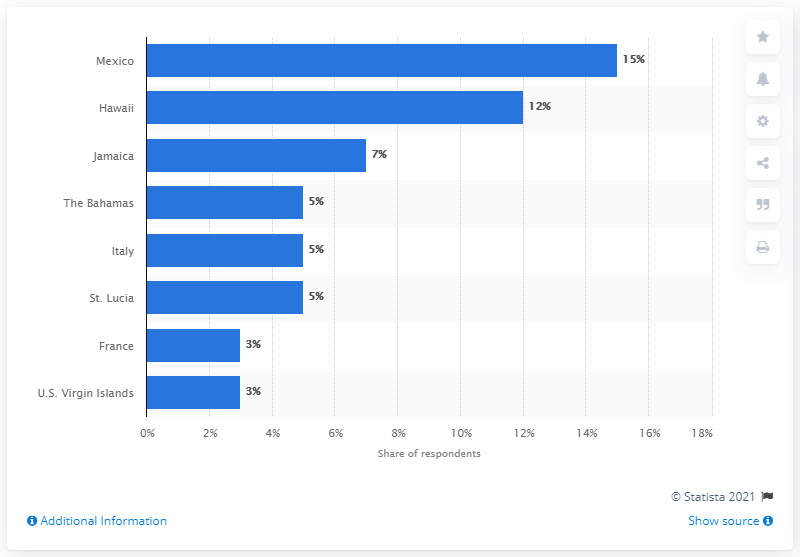What trends are influencing honeymoon destination choices today? Recent trends include adventure travel, eco-friendly accommodations, gastronomy experiences, and unique cultural immersion. Couples are increasingly seeking destinations that offer a combination of relaxation and meaningful activities. 